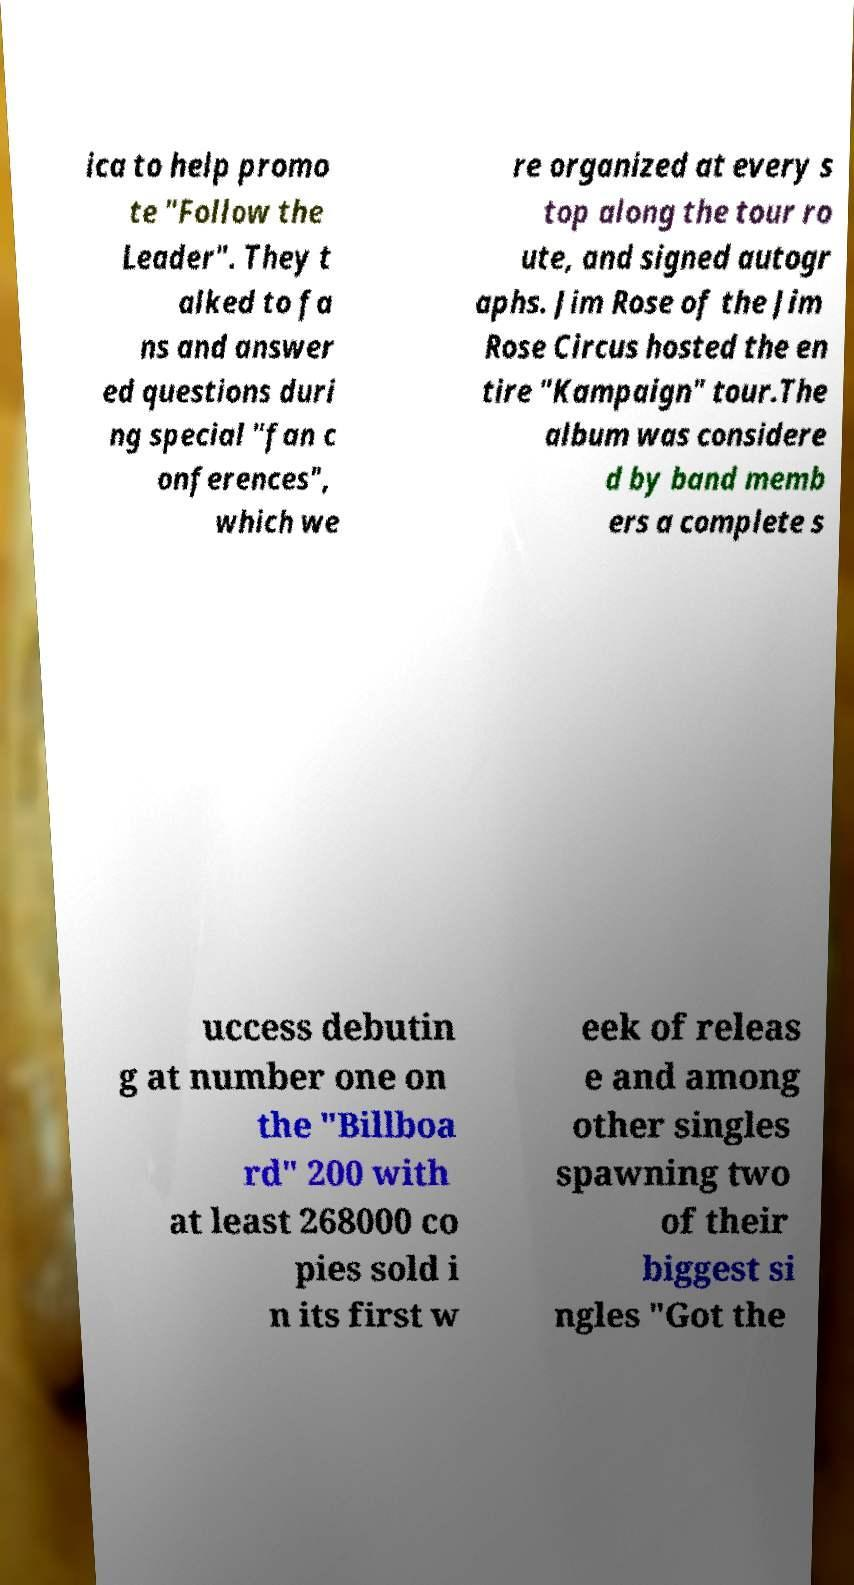Please read and relay the text visible in this image. What does it say? ica to help promo te "Follow the Leader". They t alked to fa ns and answer ed questions duri ng special "fan c onferences", which we re organized at every s top along the tour ro ute, and signed autogr aphs. Jim Rose of the Jim Rose Circus hosted the en tire "Kampaign" tour.The album was considere d by band memb ers a complete s uccess debutin g at number one on the "Billboa rd" 200 with at least 268000 co pies sold i n its first w eek of releas e and among other singles spawning two of their biggest si ngles "Got the 